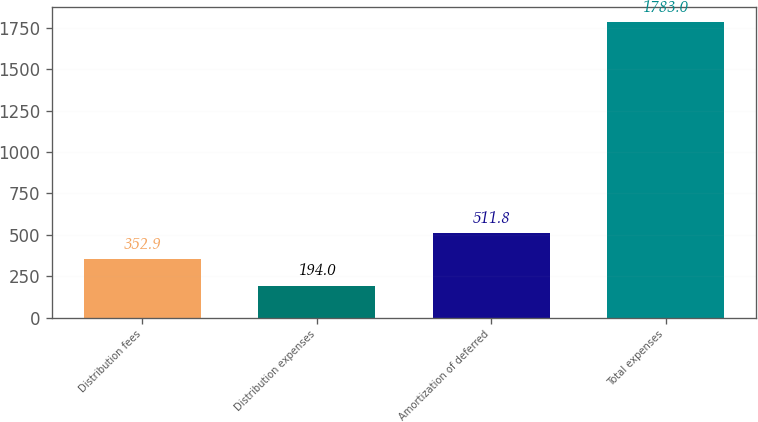Convert chart to OTSL. <chart><loc_0><loc_0><loc_500><loc_500><bar_chart><fcel>Distribution fees<fcel>Distribution expenses<fcel>Amortization of deferred<fcel>Total expenses<nl><fcel>352.9<fcel>194<fcel>511.8<fcel>1783<nl></chart> 